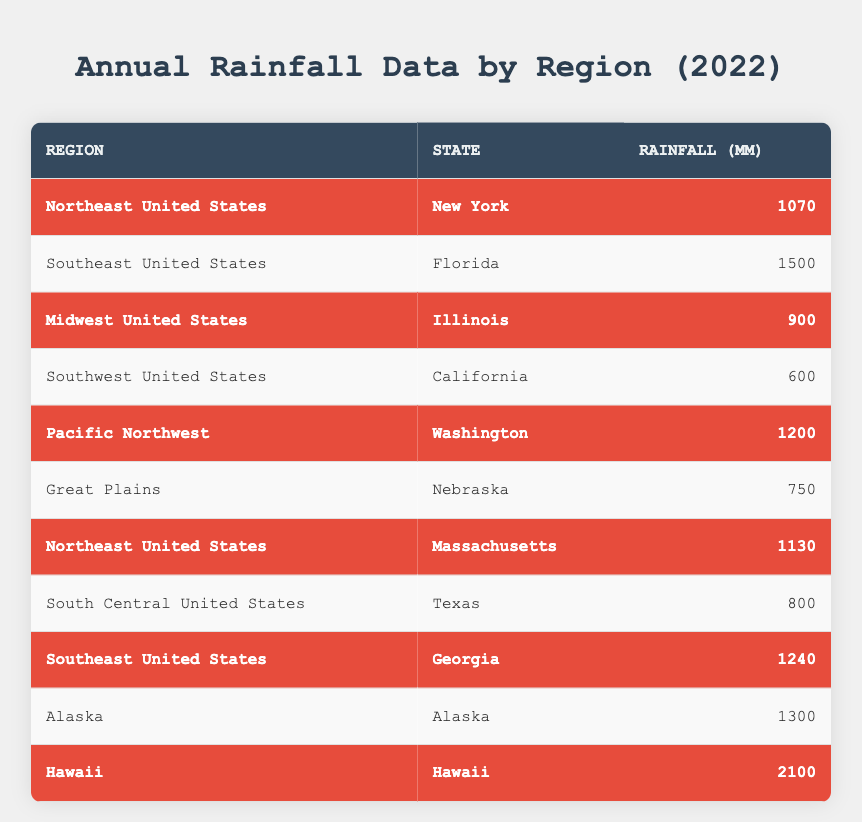What region recorded the highest annual rainfall in 2022? By analyzing the table, we can see that Hawaii has the highest rainfall value of 2100 mm listed under the region Hawaii.
Answer: Hawaii How much rainfall did Massachusetts receive in 2022? The table shows that Massachusetts, located in the Northeast United States, received 1130 mm of rainfall.
Answer: 1130 mm What is the average annual rainfall for the highlighted states? The highlighted states are New York (1070 mm), Illinois (900 mm), Washington (1200 mm), Massachusetts (1130 mm), Georgia (1240 mm), and Hawaii (2100 mm). Summing these values gives 1070 + 900 + 1200 + 1130 + 1240 + 2100 = 10140 mm. There are 6 states, so the average is 10140 / 6 = 1690 mm.
Answer: 1690 mm Was the rainfall in Florida greater than the rainfall in California? The table shows Florida received 1500 mm and California received 600 mm. Since 1500 mm is greater than 600 mm, the statement is true.
Answer: Yes What is the total rainfall for all states in the Southeast United States? In the table, the Southeast United States has two states: Florida (1500 mm) and Georgia (1240 mm). Adding these values gives 1500 + 1240 = 2740 mm.
Answer: 2740 mm How does the rainfall in the Northeast United States compare between New York and Massachusetts? The table shows New York had 1070 mm and Massachusetts had 1130 mm. Since 1130 mm is greater than 1070 mm, Massachusetts received more rainfall than New York.
Answer: Massachusetts received more rainfall What is the difference in rainfall between the highest (Hawaii) and the lowest (California) rainfall recorded? Hawaii received 2100 mm while California received 600 mm. The difference is calculated as 2100 - 600 = 1500 mm.
Answer: 1500 mm Which state had the second-highest rainfall in the year 2022? By reviewing the rainfall amounts, Hawaii has the highest (2100 mm), followed by Georgia with 1240 mm as the second-highest value in the table.
Answer: Georgia How many states reported more than 1000 mm of rainfall in 2022? The states with more than 1000 mm of rainfall are New York (1070 mm), Massachusetts (1130 mm), Washington (1200 mm), Georgia (1240 mm), and Hawaii (2100 mm). This totals to 5 states.
Answer: 5 states Is it true that Texas had a higher rainfall than Nebraska in 2022? Texas received 800 mm while Nebraska received 750 mm. Since 800 mm is greater than 750 mm, the statement is true.
Answer: Yes 